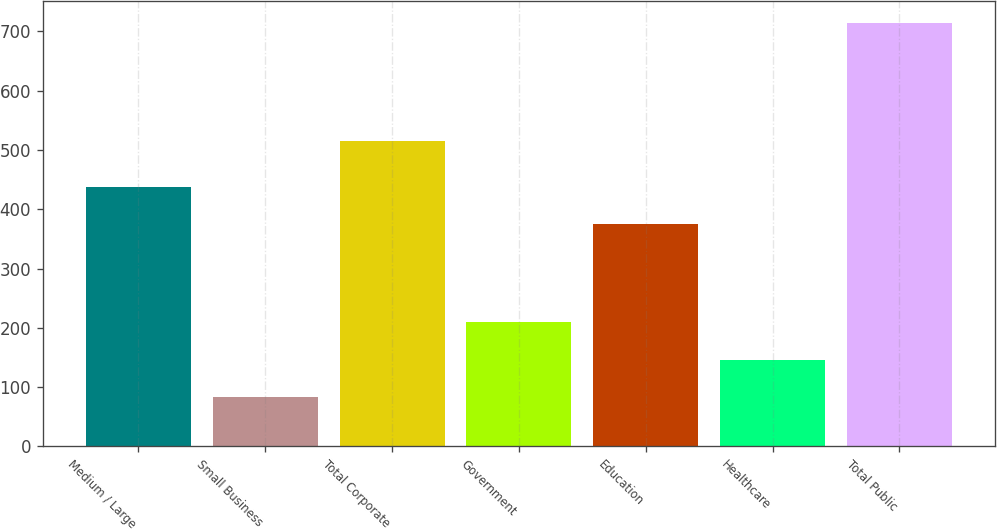Convert chart to OTSL. <chart><loc_0><loc_0><loc_500><loc_500><bar_chart><fcel>Medium / Large<fcel>Small Business<fcel>Total Corporate<fcel>Government<fcel>Education<fcel>Healthcare<fcel>Total Public<nl><fcel>438.22<fcel>82.7<fcel>515.4<fcel>209.14<fcel>375<fcel>145.92<fcel>714.9<nl></chart> 